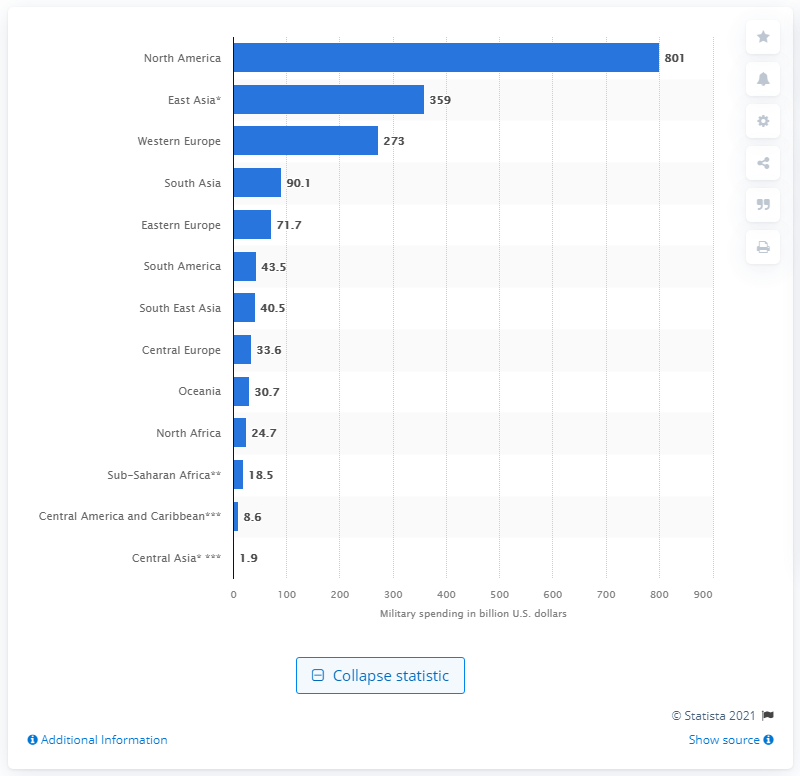Give some essential details in this illustration. In 2020, the military spending of North America was 801... I'm sorry, but the information you provided is not clear or complete. Could you please provide the complete sentence or context so I can better understand what you are asking? 